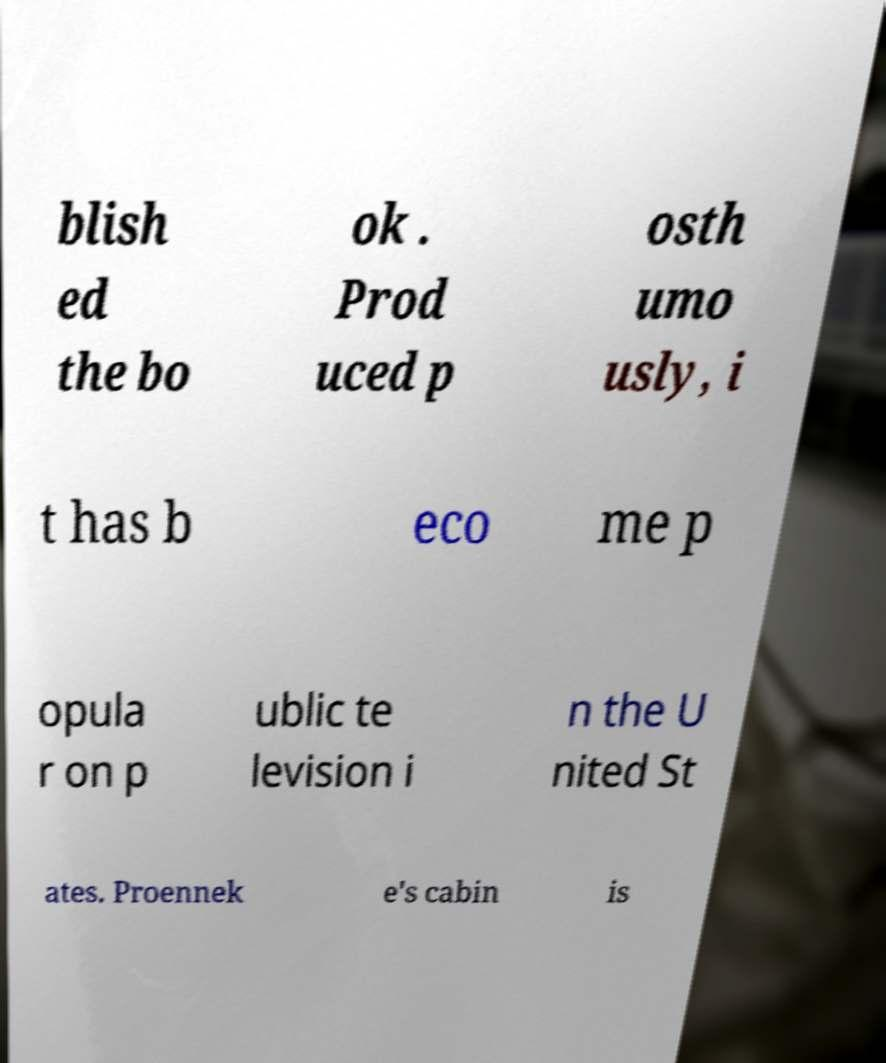I need the written content from this picture converted into text. Can you do that? blish ed the bo ok . Prod uced p osth umo usly, i t has b eco me p opula r on p ublic te levision i n the U nited St ates. Proennek e's cabin is 